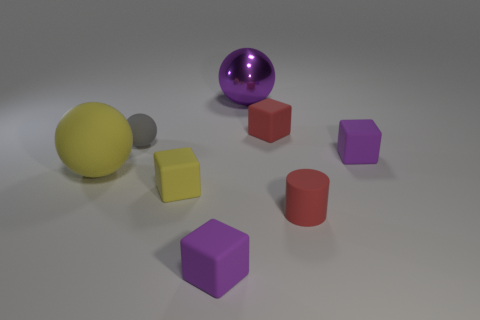Subtract all gray balls. How many balls are left? 2 Add 1 purple shiny balls. How many objects exist? 9 Subtract all spheres. How many objects are left? 5 Subtract 2 blocks. How many blocks are left? 2 Subtract all big yellow spheres. Subtract all red matte cylinders. How many objects are left? 6 Add 4 small things. How many small things are left? 10 Add 1 tiny cyan shiny objects. How many tiny cyan shiny objects exist? 1 Subtract all yellow balls. How many balls are left? 2 Subtract 0 cyan spheres. How many objects are left? 8 Subtract all yellow cylinders. Subtract all purple cubes. How many cylinders are left? 1 